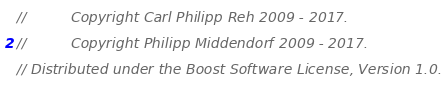Convert code to text. <code><loc_0><loc_0><loc_500><loc_500><_C++_>//          Copyright Carl Philipp Reh 2009 - 2017.
//          Copyright Philipp Middendorf 2009 - 2017.
// Distributed under the Boost Software License, Version 1.0.</code> 